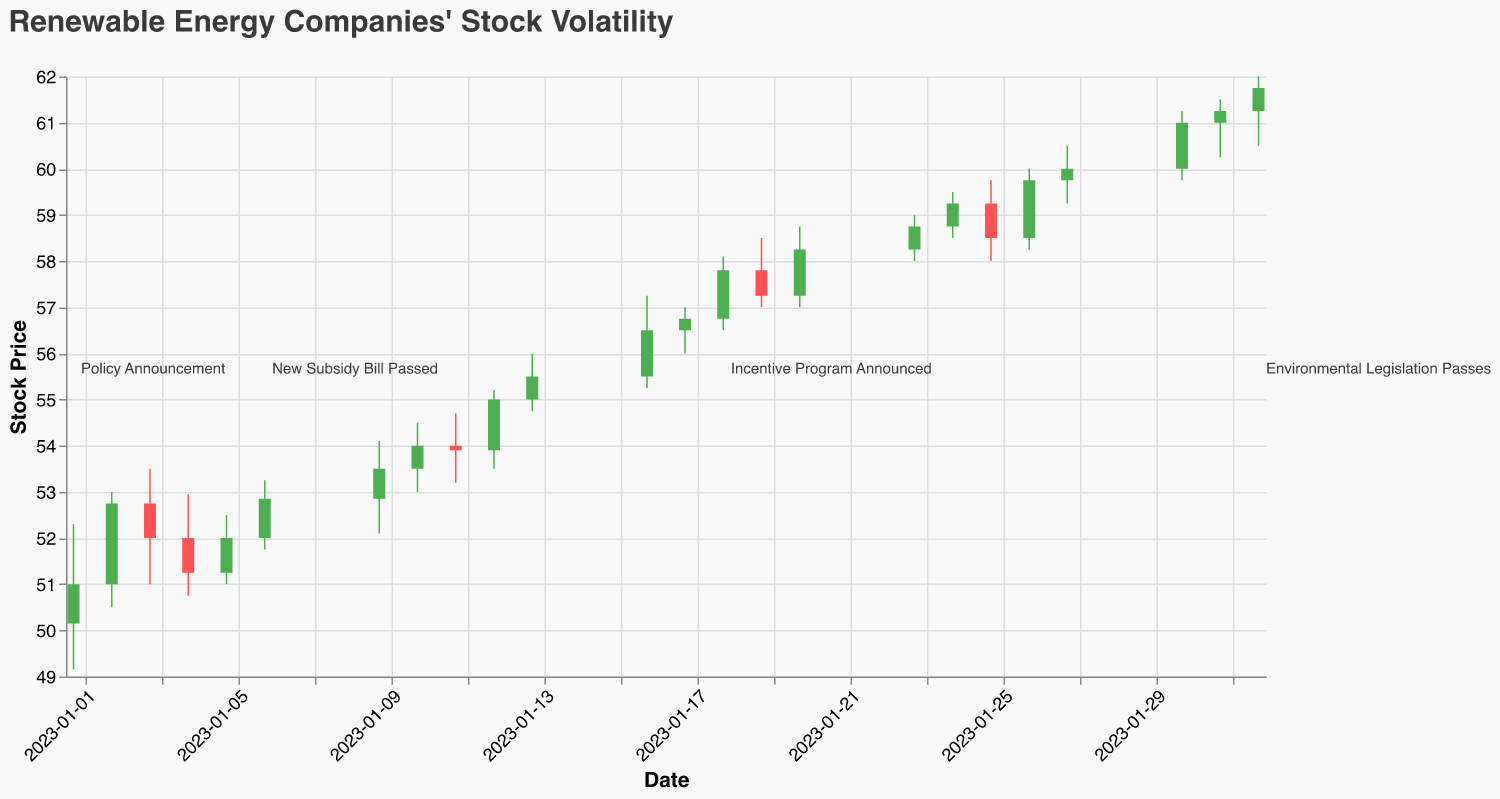What is the general trend of the stock price over the given timeframe? The stock price generally increases from January 1, 2023, to February 1, 2023. Starting at $51.00 on January 1 and closing at $61.75 on February 1. The candlestick plot shows an upward trend with green bars indicating days where the close price is higher than the open price.
Answer: Generally increasing What significant policy events can be identified from the plot, and how did they impact the stock price? There are four significant events: (1) "Policy Announcement" on January 1, (2) "New Subsidy Bill Passed" on January 6, (3) "Incentive Program Announced" on January 18, and (4) "Environmental Legislation Passes" on February 1. Each event corresponds with a noticeable increase in stock price within the next few days, indicating positive impacts. For example, on January 18, the price increased from $56.75 to $57.80 immediately after the "Incentive Program Announced".
Answer: Positive impact from each event What is the highest recorded stock price within the timeframe, and when did it occur? The highest recorded stock price is $62.00 on February 1, 2023, as indicated by the "High" value on that day in the candlestick plot.
Answer: $62.00 on February 1 How did the stock price react on the day following the "New Subsidy Bill Passed" on January 6, 2023? The stock opened at $52.85 and closed at $53.50 on January 9, showing an increase in both opening and closing prices, as well as an increased trading volume of 175,000.
Answer: Price increased Compare the stock price before and after the "Incentive Program Announced" on January 18, 2023. What change occurred? On January 18, the stock opened at $56.75 and closed at $57.80. On January 17, the stock opened at $56.50 and closed at $56.75. Therefore, there was a visible increase in both opening and closing prices following the announcement.
Answer: Increased What was the closing price on the day the "Environmental Legislation Passes"? The closing price on February 1, 2023, was $61.75, as shown in the candlestick representing the data for that day.
Answer: $61.75 Which day had the highest trading volume and what was the volume? The highest trading volume was on January 18, 2023, with a volume of 250,000 as indicated in the plot.
Answer: January 18, with 250,000 How does the stock volatility on January 2 compare to January 3? On January 2, the difference between the high and low prices was $53.00 - $50.50 = $2.50. On January 3, this difference was $53.50 - $51.00 = $2.50. Therefore, the volatility on both days was equal.
Answer: Equal volatility Calculate the average closing price from January 1, 2023, to January 6, 2023. Sum of closing prices: 51.00 + 52.75 + 52.00 + 51.25 + 52.00 + 52.85 = 311.85. Number of days: 6. Average closing price: 311.85 / 6 = 51.975.
Answer: 51.975 